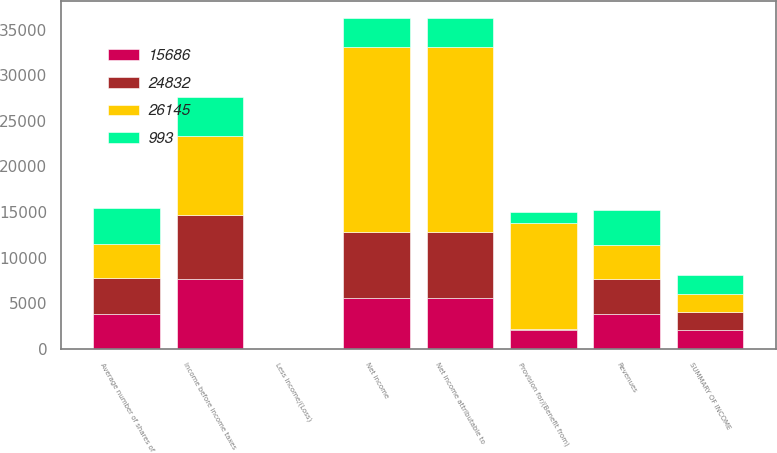Convert chart. <chart><loc_0><loc_0><loc_500><loc_500><stacked_bar_chart><ecel><fcel>SUMMARY OF INCOME<fcel>Revenues<fcel>Income before income taxes<fcel>Provision for/(Benefit from)<fcel>Net income<fcel>Less Income/(Loss)<fcel>Net income attributable to<fcel>Average number of shares of<nl><fcel>993<fcel>2014<fcel>3804<fcel>4342<fcel>1156<fcel>3186<fcel>1<fcel>3187<fcel>3912<nl><fcel>24832<fcel>2013<fcel>3804<fcel>7040<fcel>135<fcel>7175<fcel>7<fcel>7182<fcel>3935<nl><fcel>15686<fcel>2012<fcel>3804<fcel>7638<fcel>2026<fcel>5612<fcel>1<fcel>5613<fcel>3815<nl><fcel>26145<fcel>2011<fcel>3804<fcel>8646<fcel>11675<fcel>20321<fcel>9<fcel>20312<fcel>3793<nl></chart> 